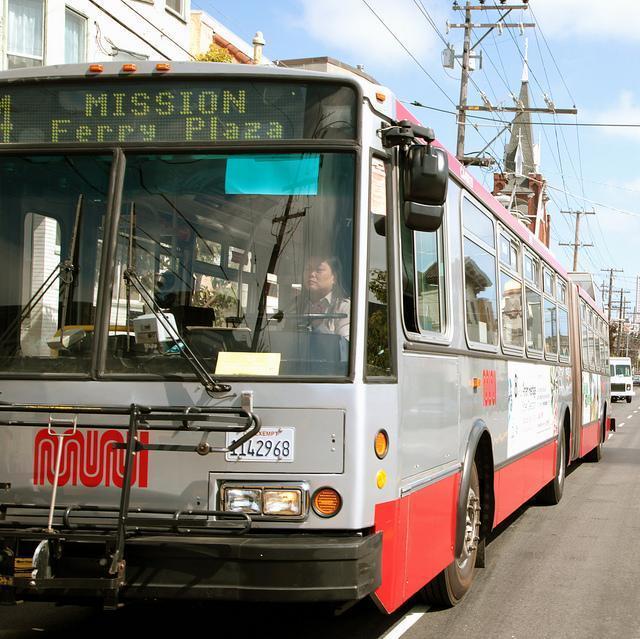Is "The bus is at the left side of the person." an appropriate description for the image?
Answer yes or no. No. 